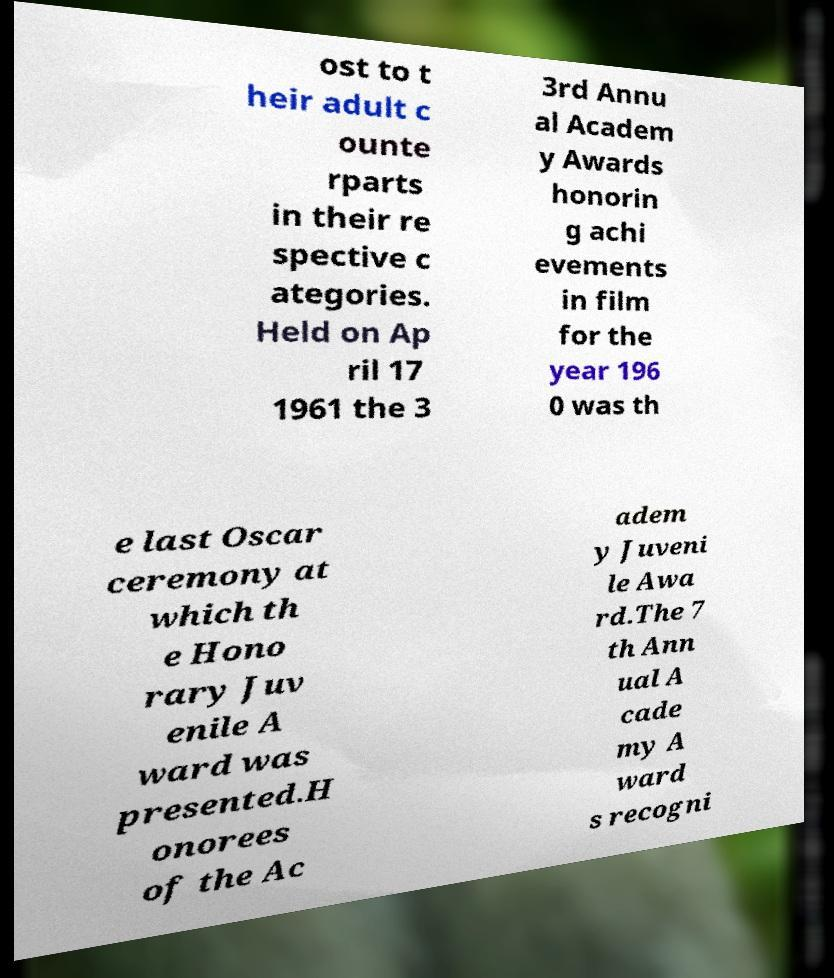Please read and relay the text visible in this image. What does it say? ost to t heir adult c ounte rparts in their re spective c ategories. Held on Ap ril 17 1961 the 3 3rd Annu al Academ y Awards honorin g achi evements in film for the year 196 0 was th e last Oscar ceremony at which th e Hono rary Juv enile A ward was presented.H onorees of the Ac adem y Juveni le Awa rd.The 7 th Ann ual A cade my A ward s recogni 